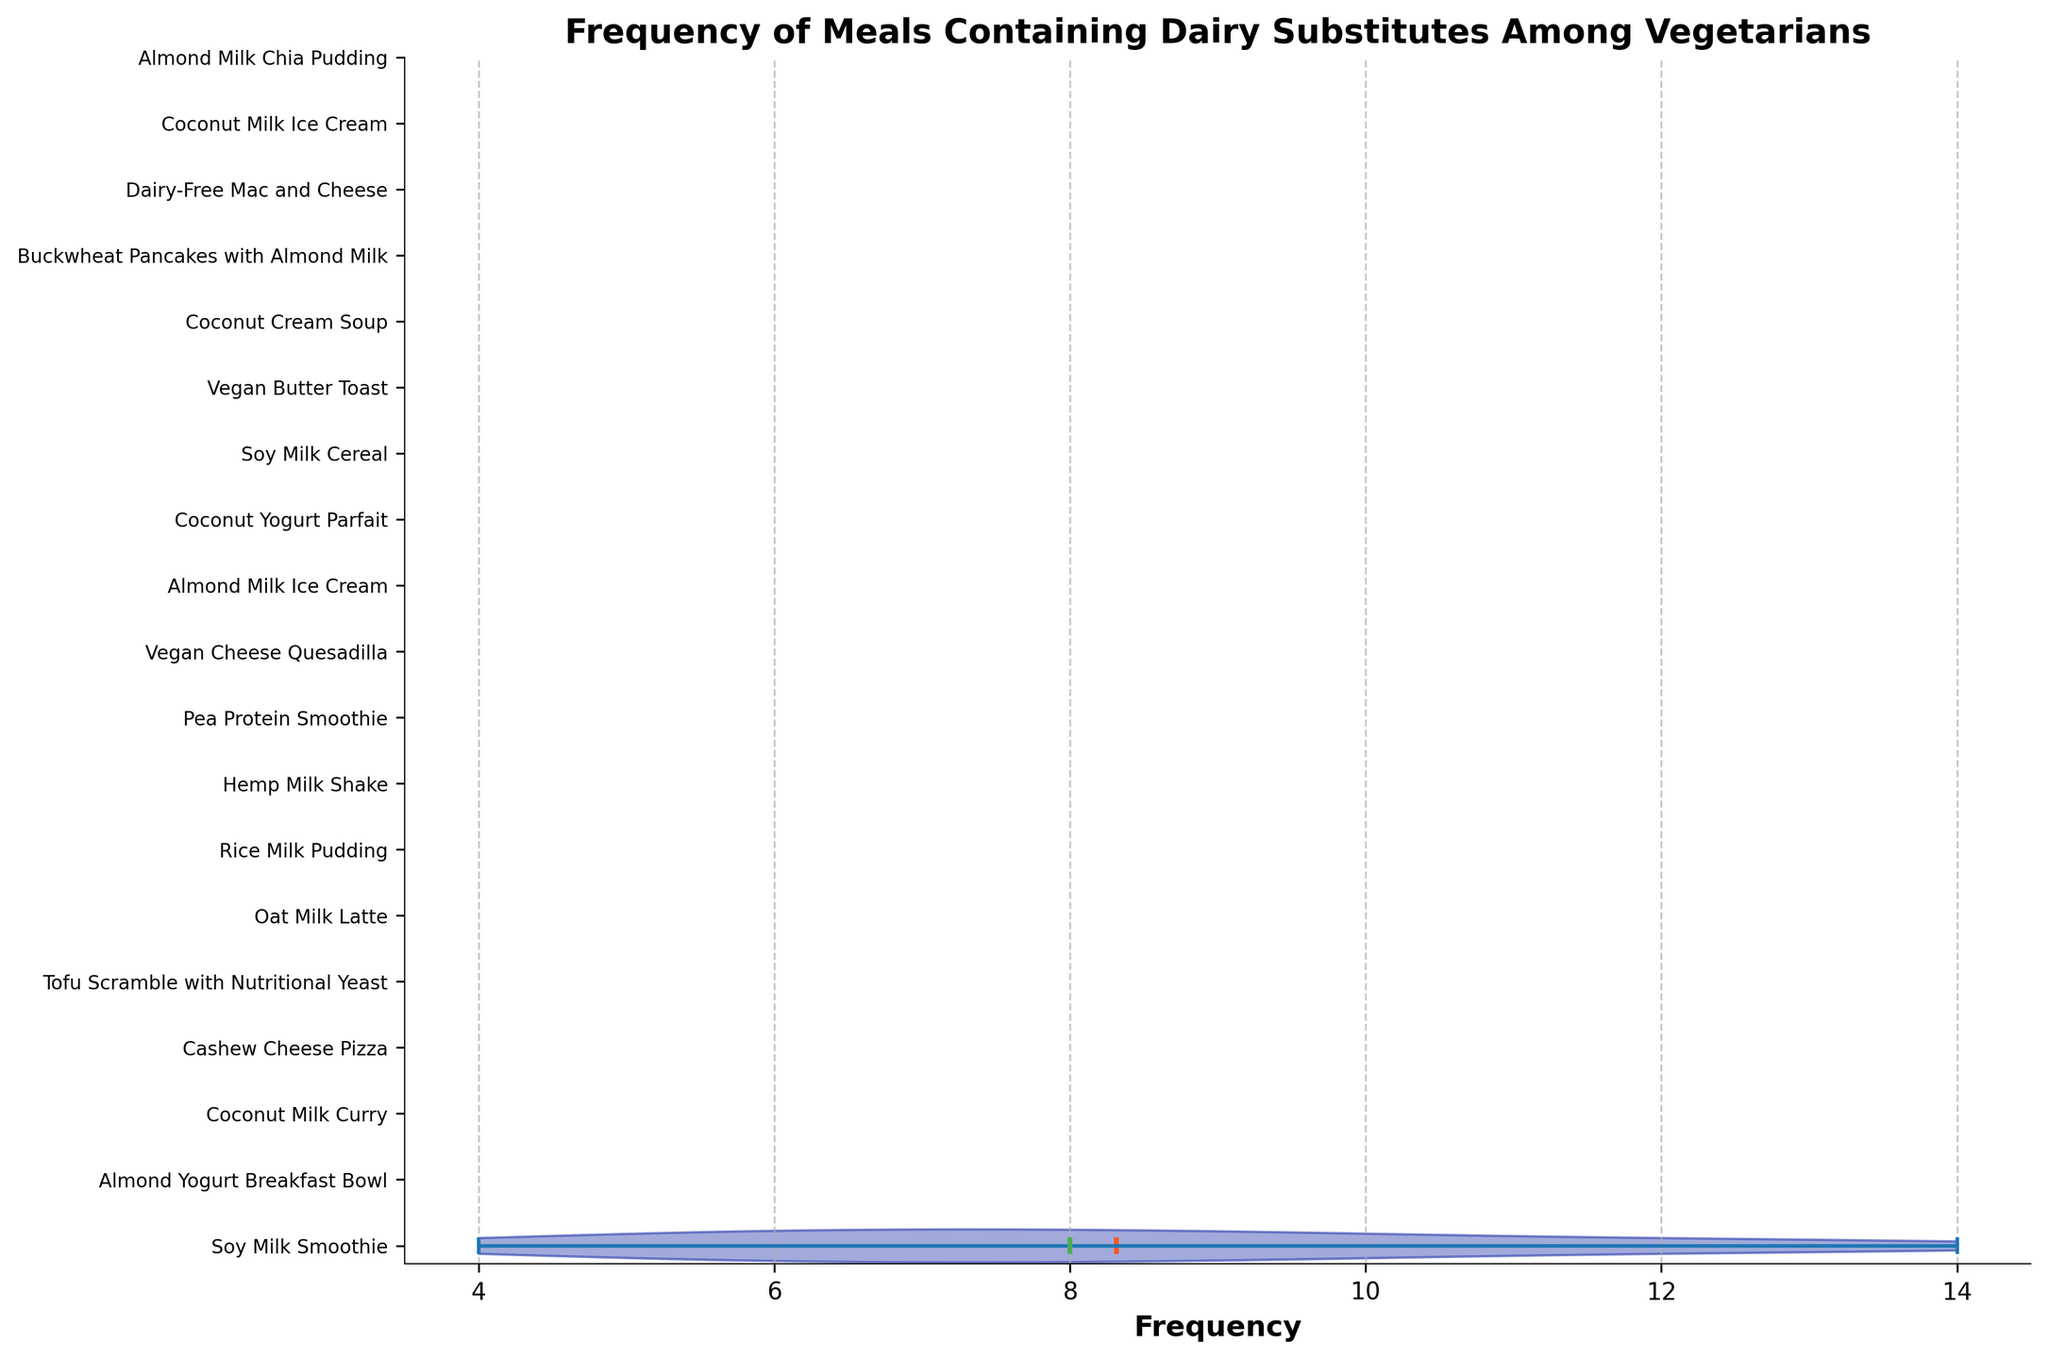What is the title of the figure? The title of the figure is displayed at the top and represents the main subject of the figure. It reads: "Frequency of Meals Containing Dairy Substitutes Among Vegetarians".
Answer: Frequency of Meals Containing Dairy Substitutes Among Vegetarians How many different meals are displayed on the y-axis? The y-axis lists all the different meals, and counting them tells us the total number. There are 19 meals displayed on the y-axis.
Answer: 19 Which meal has the highest frequency? By looking at the distribution of values, the meal with the longest distribution towards higher frequencies can be identified. The longest violin plot indicates that "Soy Milk Smoothie" has the highest frequency.
Answer: Soy Milk Smoothie What color indicates the mean values in the plots? The figure legend or description of the violin plots specifies the color used for mean values. The means are indicated by bold, orange lines.
Answer: Orange What is the median frequency of meals? Medians are represented by bold, green lines within the violin plots. To find the median meal frequency, we identify which green line (representing median) is at the middle frequency. The typical midpoint is around 8-10.
Answer: Approximately 10 Between "Vegan Cheese Quesadilla" and "Soy Milk Cereal," which one has a higher frequency? By comparing the length and position of their respective violin plots, we can determine that "Soy Milk Cereal" has a longer violin plot extending to a higher frequency.
Answer: Soy Milk Cereal What is the average frequency of the two meals with the lowest frequency? Identify the two meals with the smallest values at the end of the violin plots and their frequencies. These are "Vegan Cheese Quesadilla" and "Hemp Milk Shake" with frequencies of 4 and 5. (4 + 5) / 2 = 4.5
Answer: 4.5 How do mean and median frequencies visually differ in the figure? The mean frequencies are indicated by orange lines, while median frequencies are indicated by green lines. Both are within the violin plots, but the mean lines are likely more centrally located.
Answer: Orange lines for mean, green lines for median Do any of the meals have the same frequency? By examining the lengths and positions of the violin plots, we can see that no two plots are exactly the same length and position, thus indicating unique frequencies for each meal.
Answer: No Which indicator in the violin plots represents the median? The median is visually represented in the plots using bold, green lines. This helps to distinguish it from mean values and other features in the plot.
Answer: Green lines 